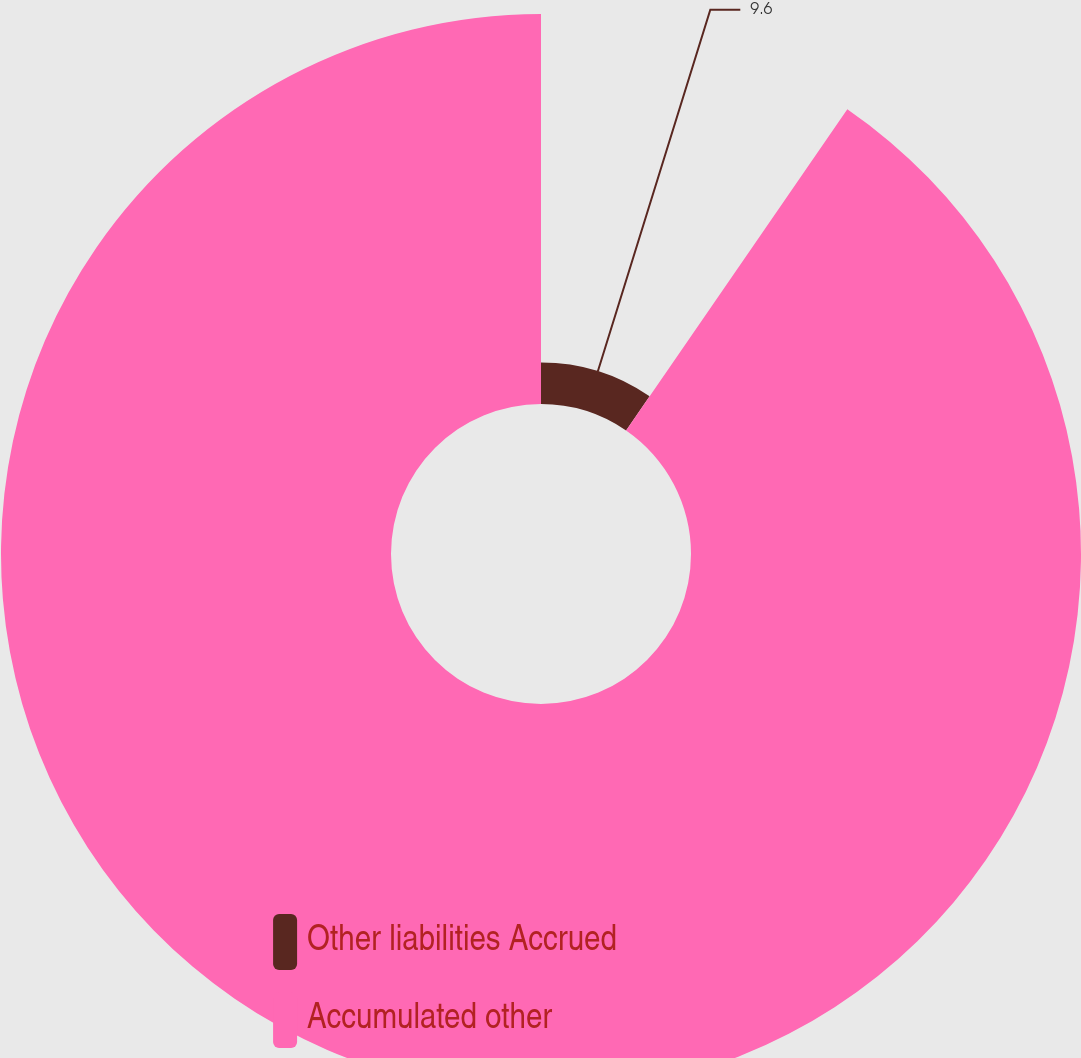Convert chart. <chart><loc_0><loc_0><loc_500><loc_500><pie_chart><fcel>Other liabilities Accrued<fcel>Accumulated other<nl><fcel>9.6%<fcel>90.4%<nl></chart> 